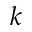<formula> <loc_0><loc_0><loc_500><loc_500>k</formula> 